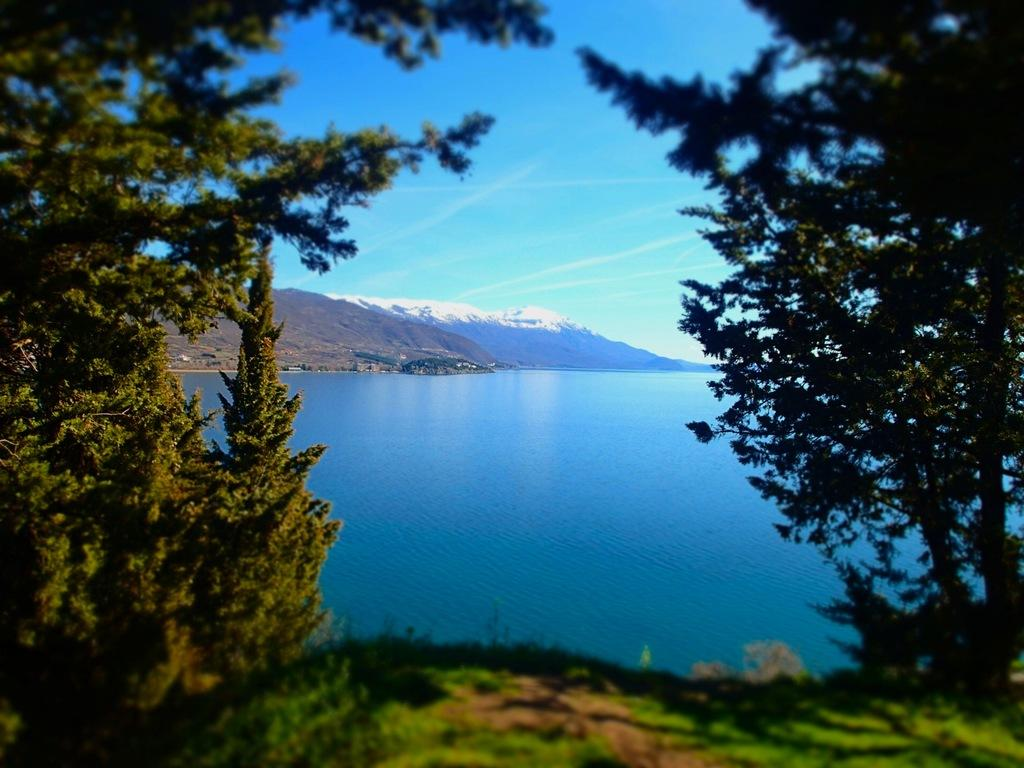Where was the image taken? The image was taken outside. What can be seen on the left side of the image? There are trees on the left side of the image. What can be seen on the right side of the image? There are trees on the right side of the image. What is in the middle of the image? There is water and mountains in the middle of the image. What is visible at the top of the image? The sky is visible at the top of the image. What type of company is depicted in the image? There is no company present in the image; it features natural elements such as trees, water, mountains, and sky. Can you tell me how many attempts were made to fly in the image? There is no reference to any attempts to fly in the image. 